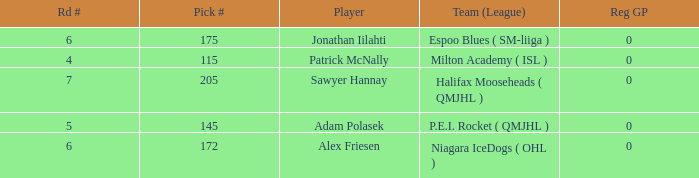What's sawyer hannay's total pick number? 1.0. 